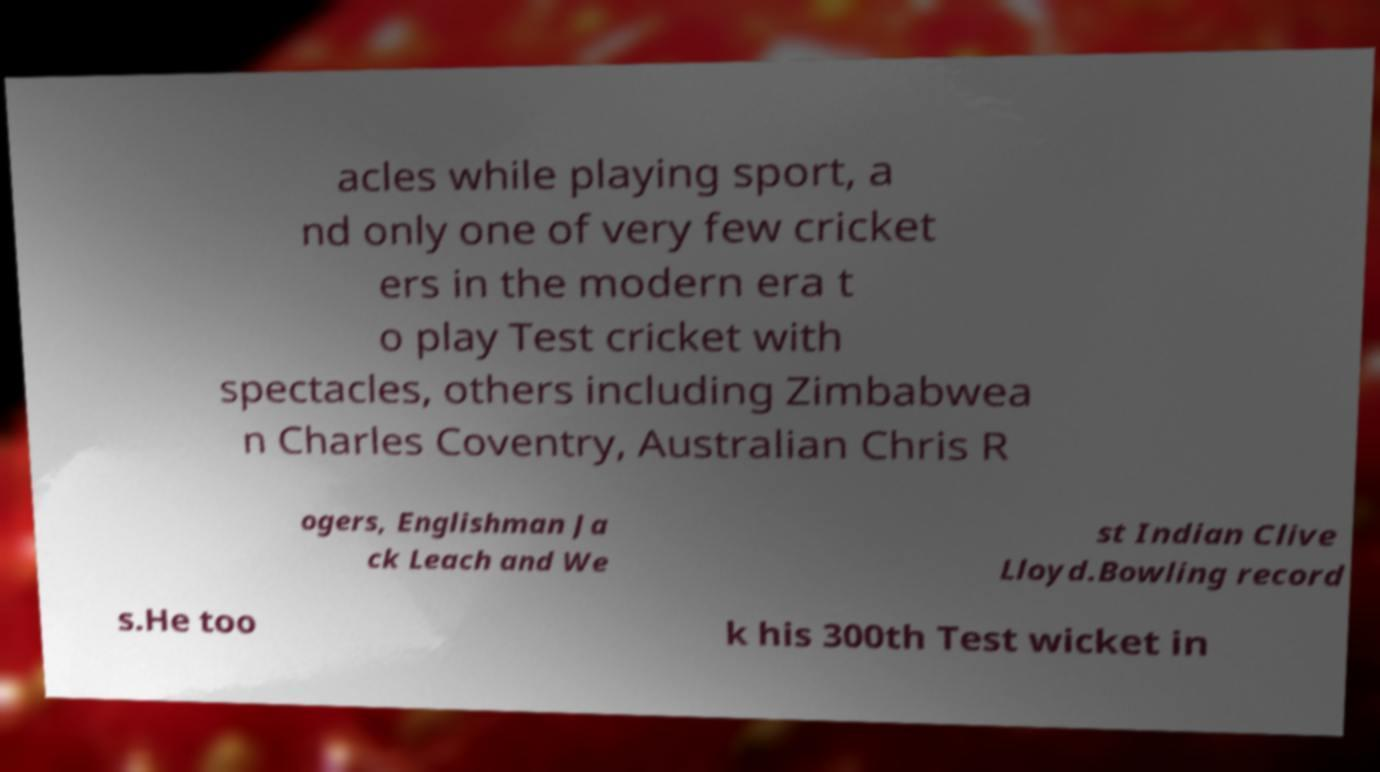There's text embedded in this image that I need extracted. Can you transcribe it verbatim? acles while playing sport, a nd only one of very few cricket ers in the modern era t o play Test cricket with spectacles, others including Zimbabwea n Charles Coventry, Australian Chris R ogers, Englishman Ja ck Leach and We st Indian Clive Lloyd.Bowling record s.He too k his 300th Test wicket in 